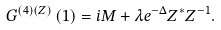Convert formula to latex. <formula><loc_0><loc_0><loc_500><loc_500>G ^ { \left ( 4 \right ) \left ( Z \right ) } \left ( 1 \right ) = i M + \lambda e ^ { - \Delta } Z ^ { \ast } Z ^ { - 1 } .</formula> 